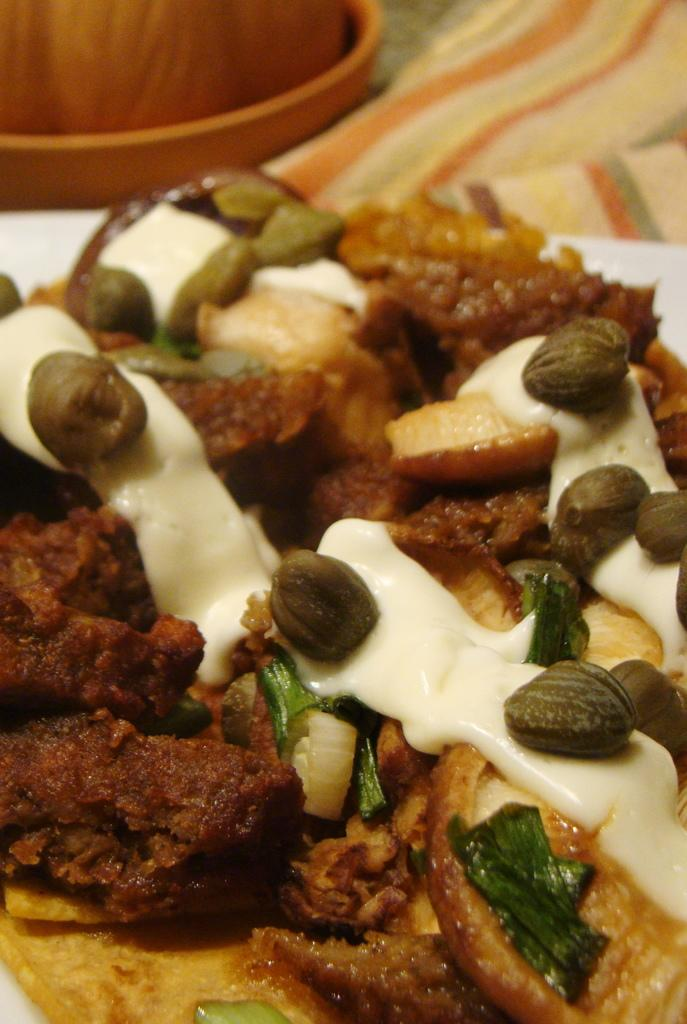What is the main characteristic of the food item in the image? The food item has white cream. What else can be seen on the food item? The food item has green leaves and many other things. Can you describe the wooden object in the background? There is a wooden object in the background, but its specific characteristics are not mentioned in the facts. What type of soap is being used to clean the company's logo in the image? There is no soap or company logo present in the image. 